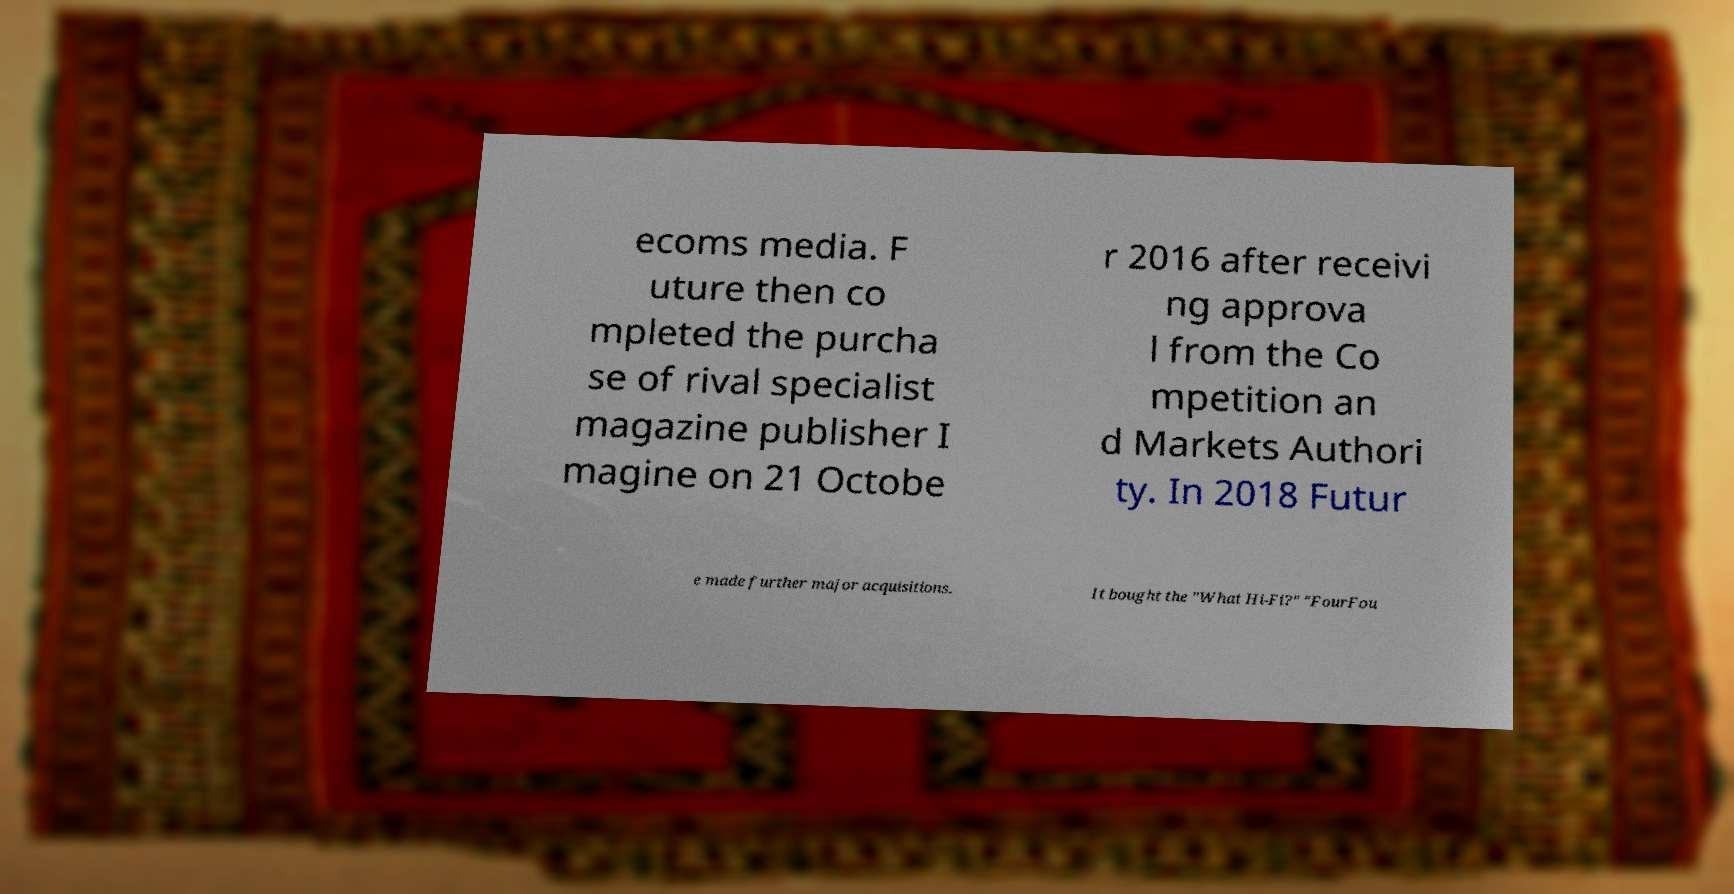Could you extract and type out the text from this image? ecoms media. F uture then co mpleted the purcha se of rival specialist magazine publisher I magine on 21 Octobe r 2016 after receivi ng approva l from the Co mpetition an d Markets Authori ty. In 2018 Futur e made further major acquisitions. It bought the "What Hi-Fi?" "FourFou 